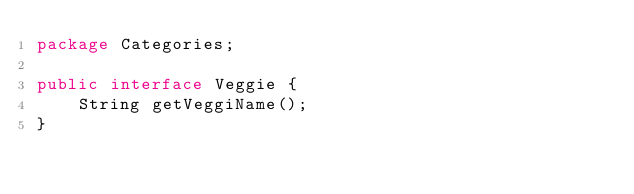<code> <loc_0><loc_0><loc_500><loc_500><_Java_>package Categories;

public interface Veggie {
	String getVeggiName();
}
</code> 